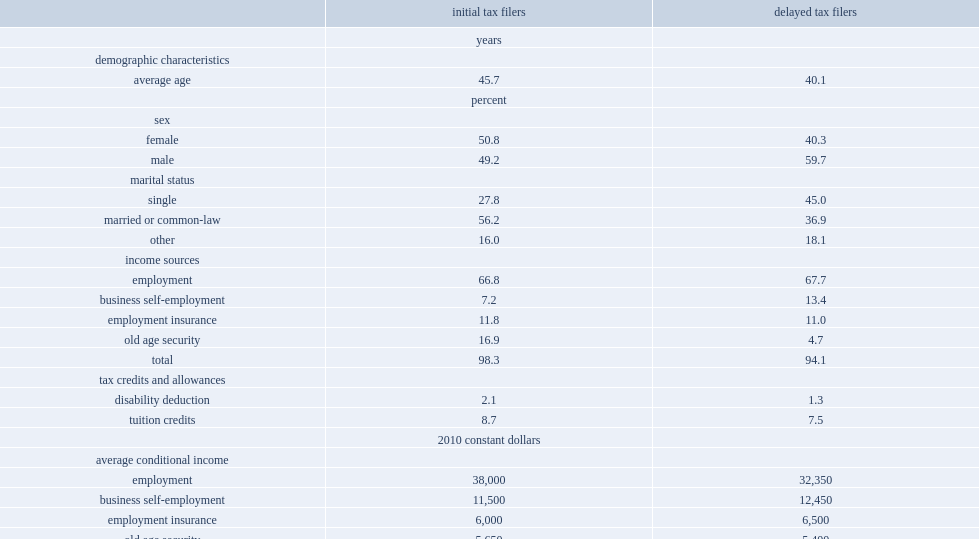Who were more likely to be younger,delayed tax filers or initial tax filers? Delayed tax filers. Who were more likely to be male,delayed tax filers or initial tax filers? Delayed tax filers. Who was more likely to be married or in common-law relationships, delayed tax filers or initial tax filers? Initial tax filers. Who were more likely to have oas income,delayed tax filers or initial tax filers? Delayed tax filers. Who were more likely to have business self-employment income, delayed tax filers or initial tax filers? Delayed tax filers. Who were more likely to earn more in employment earnings, delayed tax filers or initial tax filers? Initial tax filers. 